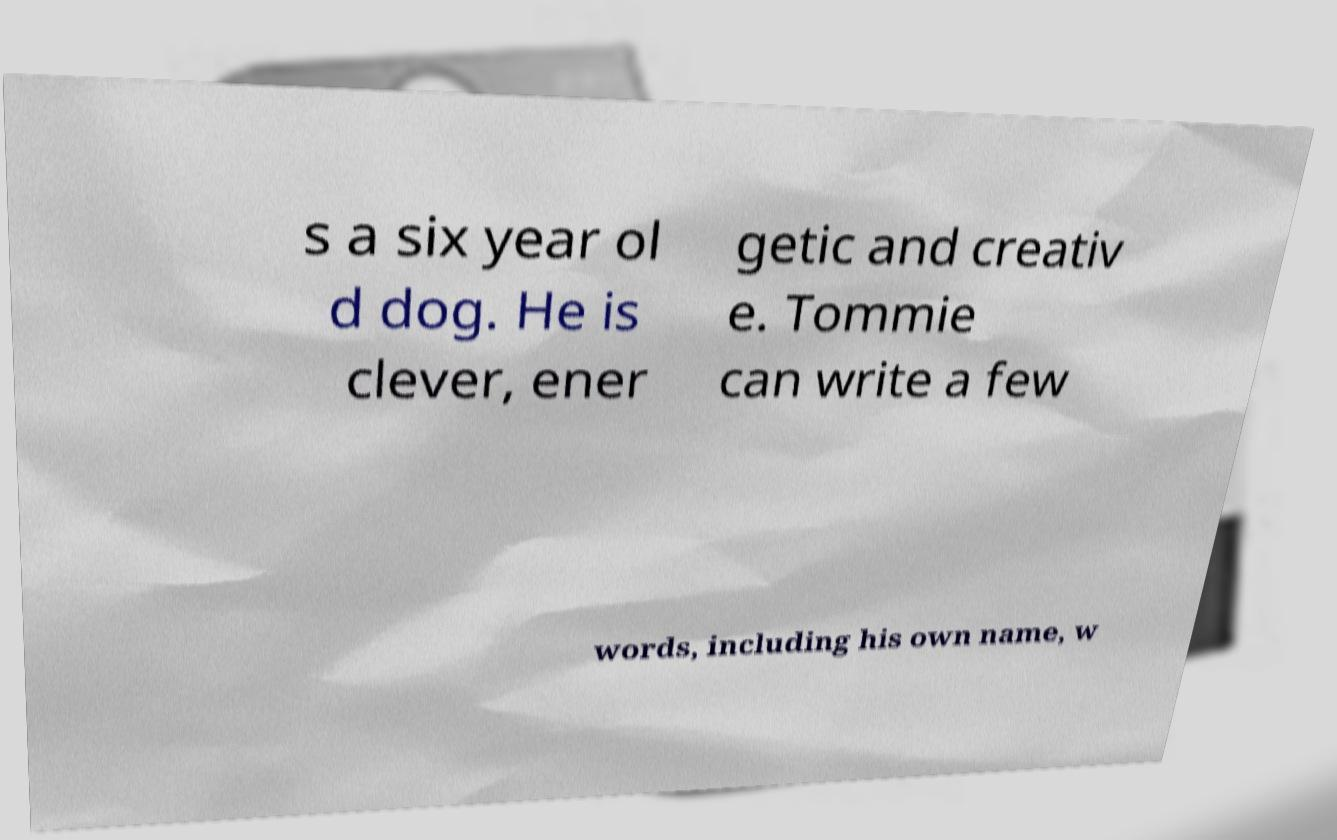Can you accurately transcribe the text from the provided image for me? s a six year ol d dog. He is clever, ener getic and creativ e. Tommie can write a few words, including his own name, w 